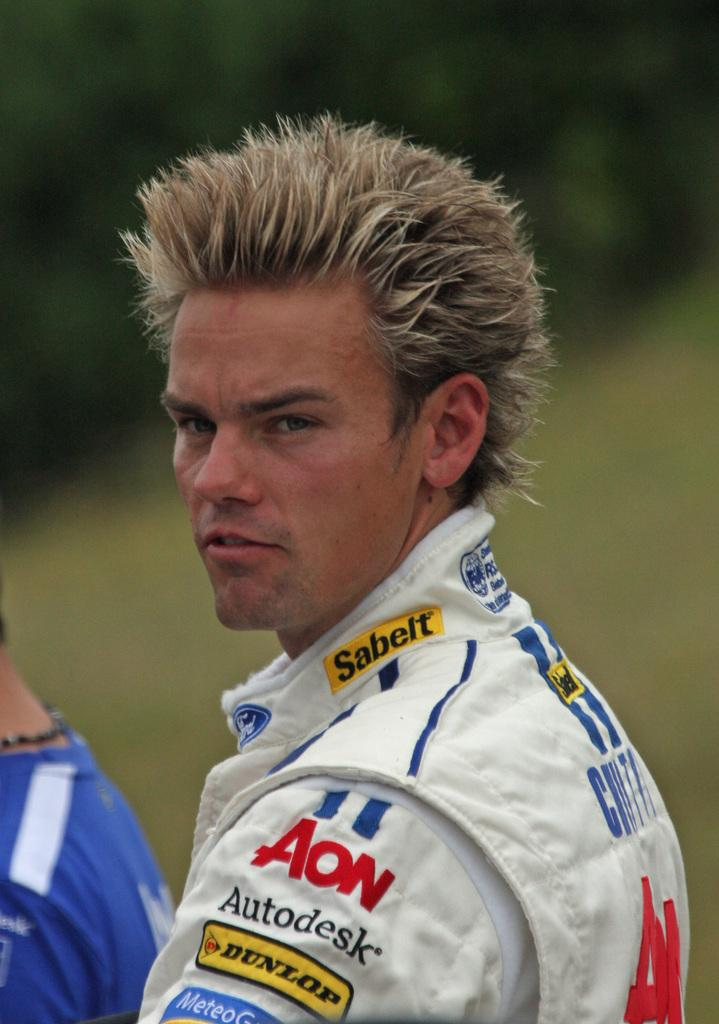Provide a one-sentence caption for the provided image. The man with spiky hair is sponsored by Autodesk. 